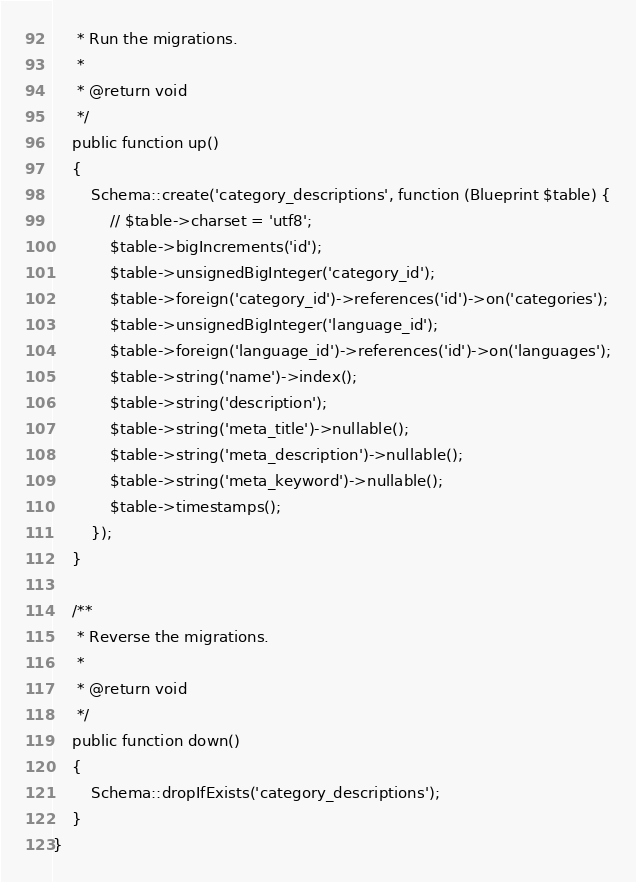<code> <loc_0><loc_0><loc_500><loc_500><_PHP_>     * Run the migrations.
     *
     * @return void
     */
    public function up()
    {
        Schema::create('category_descriptions', function (Blueprint $table) {
            // $table->charset = 'utf8';
            $table->bigIncrements('id');
            $table->unsignedBigInteger('category_id');
            $table->foreign('category_id')->references('id')->on('categories');
            $table->unsignedBigInteger('language_id');
            $table->foreign('language_id')->references('id')->on('languages');
            $table->string('name')->index();
            $table->string('description');
            $table->string('meta_title')->nullable();
            $table->string('meta_description')->nullable();
            $table->string('meta_keyword')->nullable();
            $table->timestamps();
        });
    }

    /**
     * Reverse the migrations.
     *
     * @return void
     */
    public function down()
    {
        Schema::dropIfExists('category_descriptions');
    }
}
</code> 